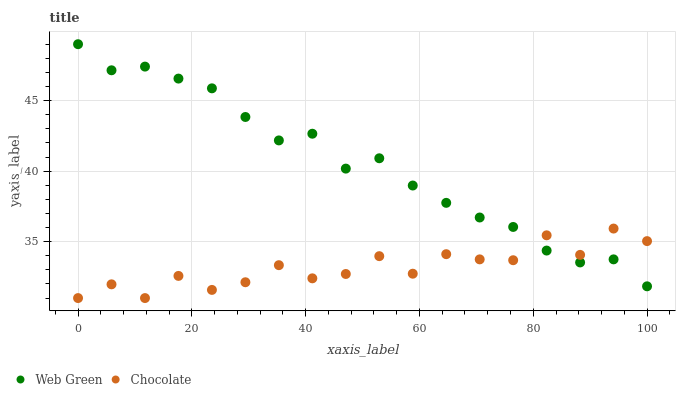Does Chocolate have the minimum area under the curve?
Answer yes or no. Yes. Does Web Green have the maximum area under the curve?
Answer yes or no. Yes. Does Chocolate have the maximum area under the curve?
Answer yes or no. No. Is Web Green the smoothest?
Answer yes or no. Yes. Is Chocolate the roughest?
Answer yes or no. Yes. Is Chocolate the smoothest?
Answer yes or no. No. Does Chocolate have the lowest value?
Answer yes or no. Yes. Does Web Green have the highest value?
Answer yes or no. Yes. Does Chocolate have the highest value?
Answer yes or no. No. Does Chocolate intersect Web Green?
Answer yes or no. Yes. Is Chocolate less than Web Green?
Answer yes or no. No. Is Chocolate greater than Web Green?
Answer yes or no. No. 